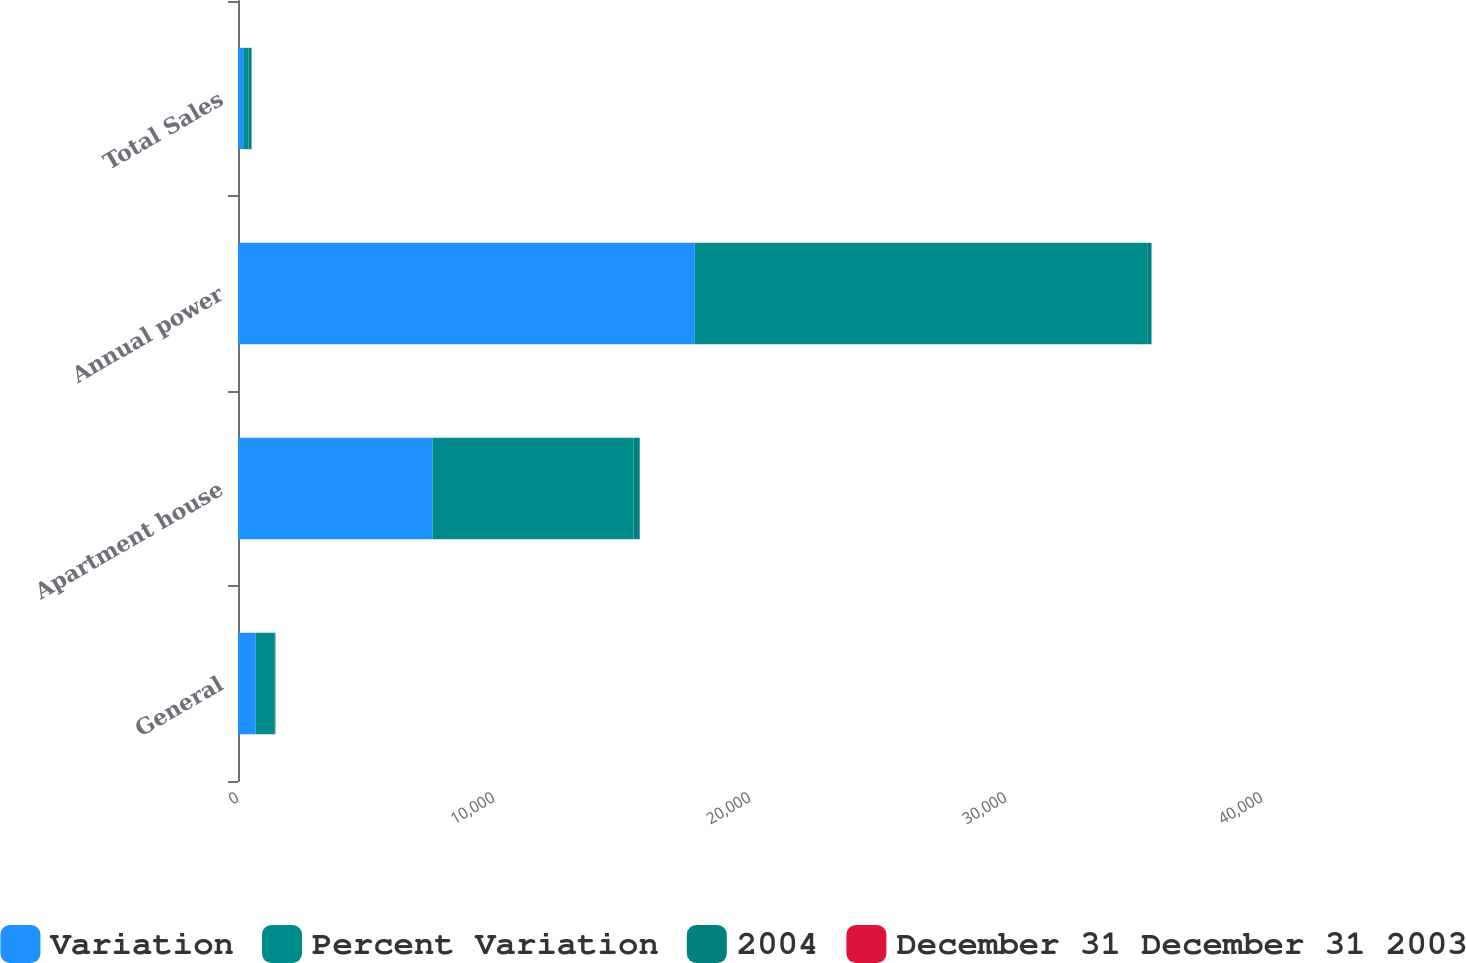Convert chart. <chart><loc_0><loc_0><loc_500><loc_500><stacked_bar_chart><ecel><fcel>General<fcel>Apartment house<fcel>Annual power<fcel>Total Sales<nl><fcel>Variation<fcel>685<fcel>7602<fcel>17842<fcel>205.5<nl><fcel>Percent Variation<fcel>729<fcel>7845<fcel>17674<fcel>205.5<nl><fcel>2004<fcel>44<fcel>243<fcel>168<fcel>119<nl><fcel>December 31 December 31 2003<fcel>6<fcel>3.1<fcel>1<fcel>0.5<nl></chart> 